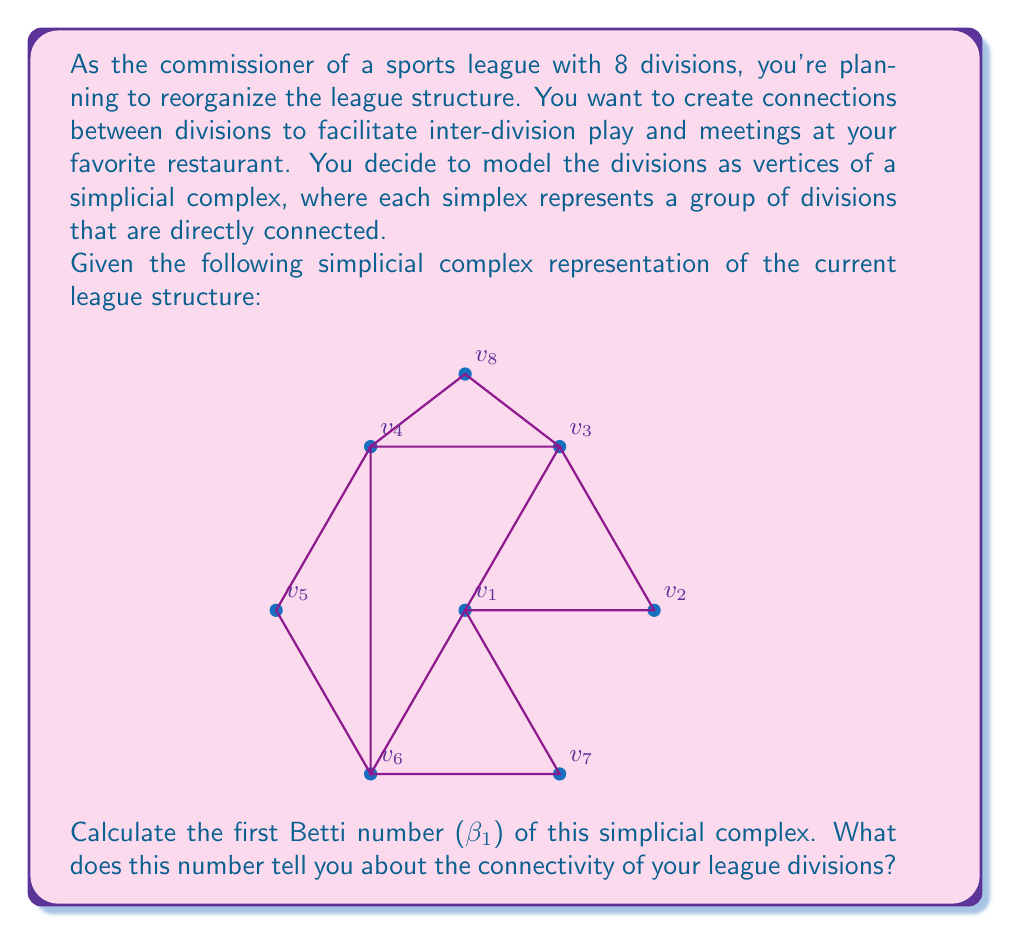Help me with this question. To solve this problem, we'll follow these steps:

1) First, let's recall what the first Betti number represents. In algebraic topology, $\beta_1$ counts the number of 1-dimensional holes in the simplicial complex.

2) To calculate $\beta_1$, we need to use the formula:

   $$\beta_1 = \text{rank}(H_1) = \text{rank}(Z_1) - \text{rank}(B_1)$$

   where $Z_1$ is the group of 1-cycles and $B_1$ is the group of 1-boundaries.

3) Let's count the relevant components:
   - 0-simplices (vertices): 8
   - 1-simplices (edges): 12
   - 2-simplices (triangles): 4

4) Now we can calculate:
   - $\text{rank}(Z_1) = \text{number of edges} - \text{rank}(d_1)$
     where $d_1$ is the boundary map from 1-chains to 0-chains.
   - $\text{rank}(d_1) = \text{number of vertices} - 1 = 7$
   - So, $\text{rank}(Z_1) = 12 - 7 = 5$

5) $\text{rank}(B_1)$ is equal to the number of independent boundaries of 2-simplices.
   With 4 triangles, $\text{rank}(B_1) = 4$

6) Therefore:
   $$\beta_1 = \text{rank}(Z_1) - \text{rank}(B_1) = 5 - 4 = 1$$

7) Interpretation: The first Betti number being 1 indicates that there is one 1-dimensional hole in the simplicial complex. In the context of the league divisions, this means there is one "loop" or "cycle" in the connection structure that is not filled in.

This suggests that while the divisions are connected, there's still room for improving connectivity. The commissioner might consider adding more connections between divisions to eliminate this hole and create a more tightly-knit league structure.
Answer: $\beta_1 = 1$, indicating one 1-dimensional hole in the division connectivity structure. 